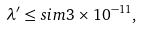Convert formula to latex. <formula><loc_0><loc_0><loc_500><loc_500>\lambda ^ { \prime } \leq s i m 3 \times 1 0 ^ { - 1 1 } ,</formula> 